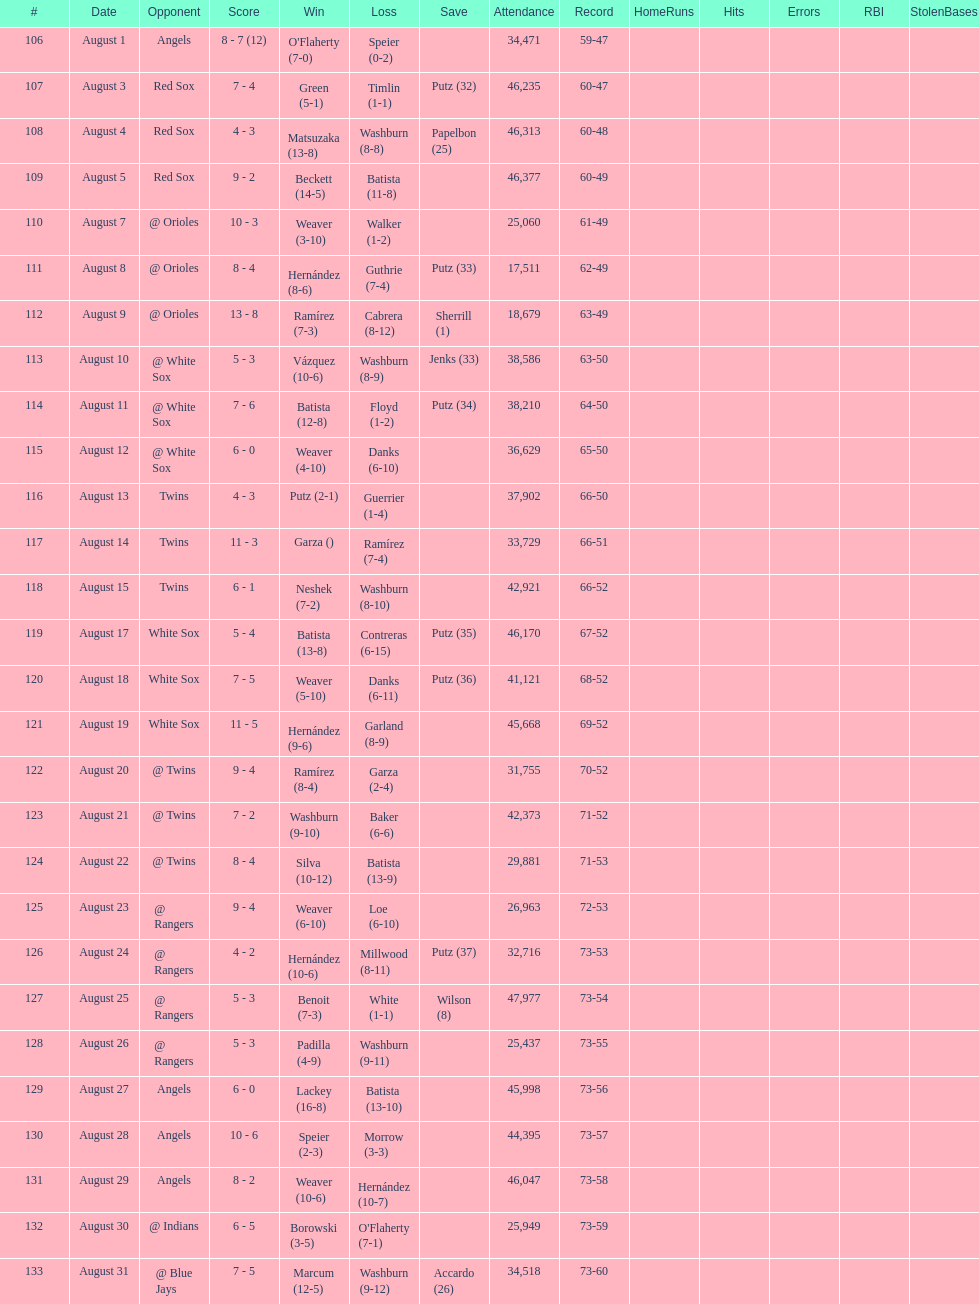Number of wins during stretch 5. 